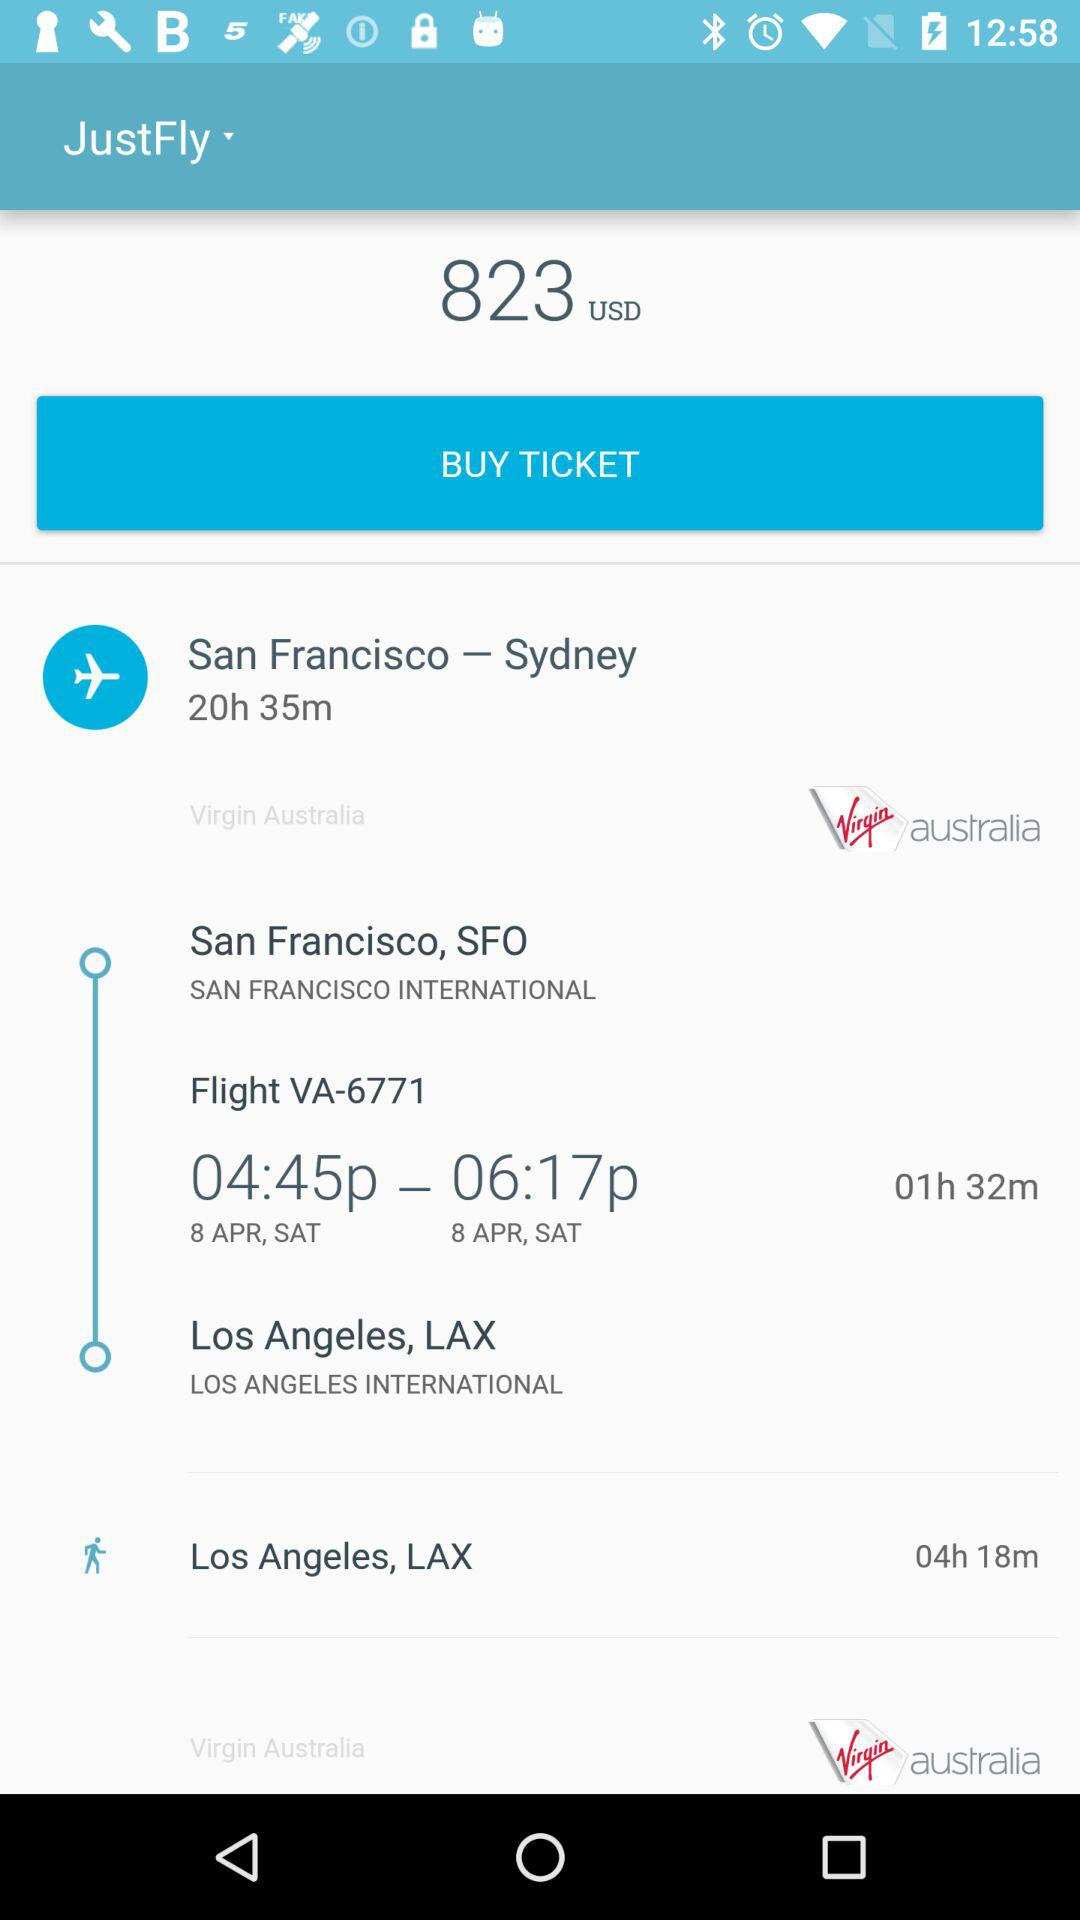How long is the layover in Los Angeles?
Answer the question using a single word or phrase. 4h 18m 